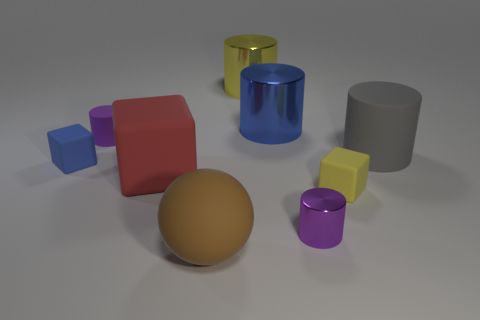Subtract all small metal cylinders. How many cylinders are left? 4 Subtract 1 cylinders. How many cylinders are left? 4 Subtract all cylinders. How many objects are left? 4 Add 1 yellow blocks. How many objects exist? 10 Subtract all yellow cylinders. How many cylinders are left? 4 Subtract 0 cyan cubes. How many objects are left? 9 Subtract all purple cylinders. Subtract all cyan balls. How many cylinders are left? 3 Subtract all blue cubes. How many purple cylinders are left? 2 Subtract all yellow rubber spheres. Subtract all yellow metal objects. How many objects are left? 8 Add 2 large red rubber cubes. How many large red rubber cubes are left? 3 